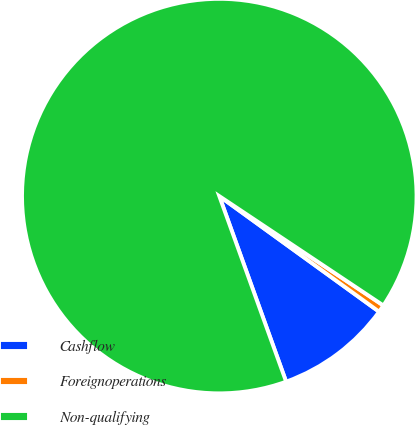<chart> <loc_0><loc_0><loc_500><loc_500><pie_chart><fcel>Cashflow<fcel>Foreignoperations<fcel>Non-qualifying<nl><fcel>9.53%<fcel>0.61%<fcel>89.86%<nl></chart> 